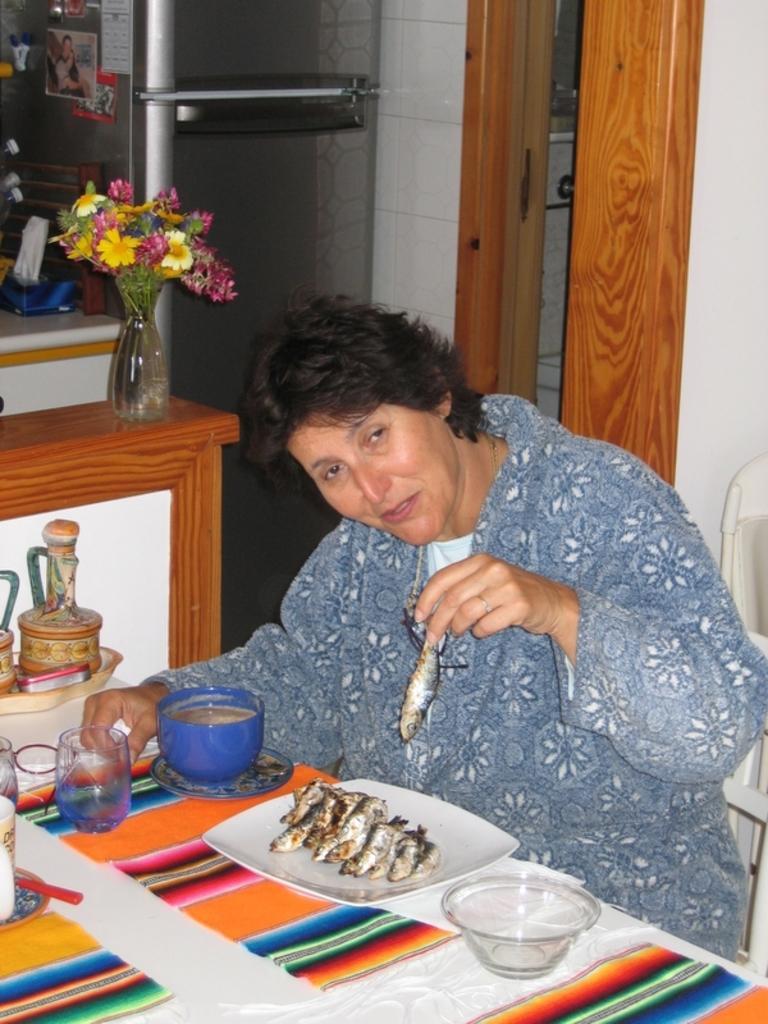In one or two sentences, can you explain what this image depicts? In the middle of the picture, we see the woman is sitting on the chair. She is smiling and she is holding a fish in her hand. In front of her, we see a table on which plate containing fishes, glass, cup, saucer, bowl, plate and a tray are placed. Beside her, we see a table on which flower vase is placed. Beside that, we see a refrigerator on which posters are pasted. On the right side, we see a white wall and a wooden door. 